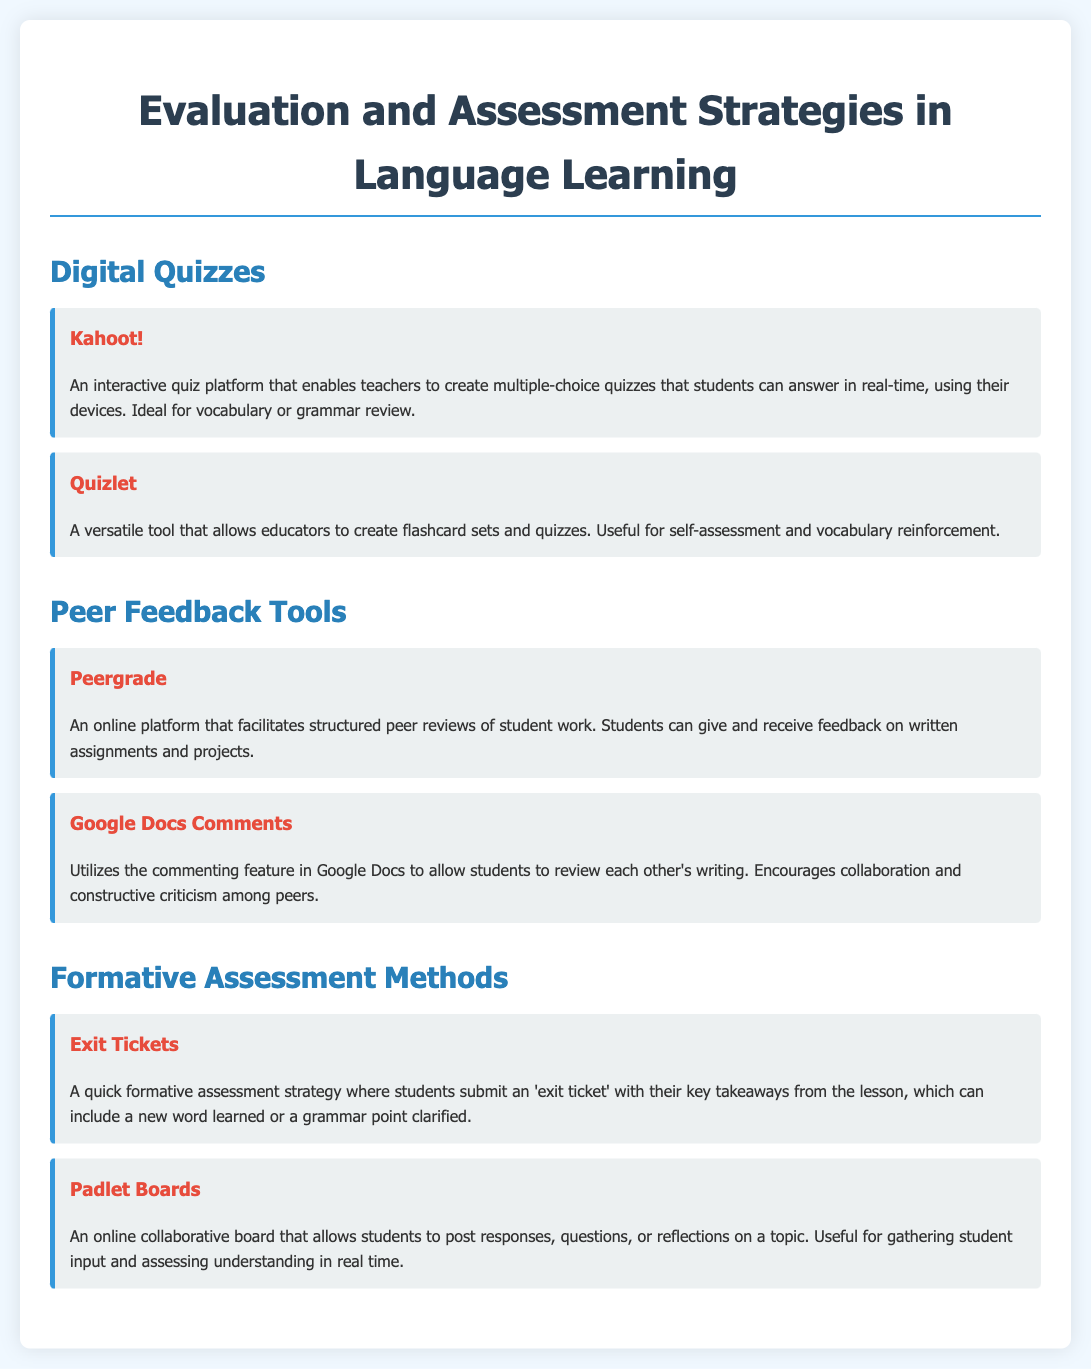What is the name of the quiz platform that allows real-time responses? The document mentions Kahoot! as an interactive quiz platform for real-time responses.
Answer: Kahoot! Which tool allows educators to create flashcard sets? Quizlet is identified as a versatile tool for creating flashcard sets and quizzes.
Answer: Quizlet What method involves students submitting key takeaways at the end of the lesson? The document describes Exit Tickets as a quick formative assessment strategy for capturing student takeaways.
Answer: Exit Tickets What online platform is mentioned for structured peer reviews? Peergrade is specified as an online platform that facilitates structured peer reviews of student work.
Answer: Peergrade Which tool utilizes commenting for peer review? Google Docs Comments is mentioned for allowing students to use comments to review each other's writing.
Answer: Google Docs Comments What is the purpose of Padlet Boards as stated in the document? Padlet Boards are used for gathering student input and assessing understanding in real time.
Answer: Gathering student input Which digital quiz tool is ideal for vocabulary or grammar review? The document states that Kahoot! is ideal for vocabulary or grammar review.
Answer: Kahoot! What color is used for the headers in the content items? The headers in the content items are depicted in color red as indicated in the style description.
Answer: Red How many digital quiz tools are listed in the document? There are two digital quiz tools mentioned: Kahoot! and Quizlet.
Answer: Two 